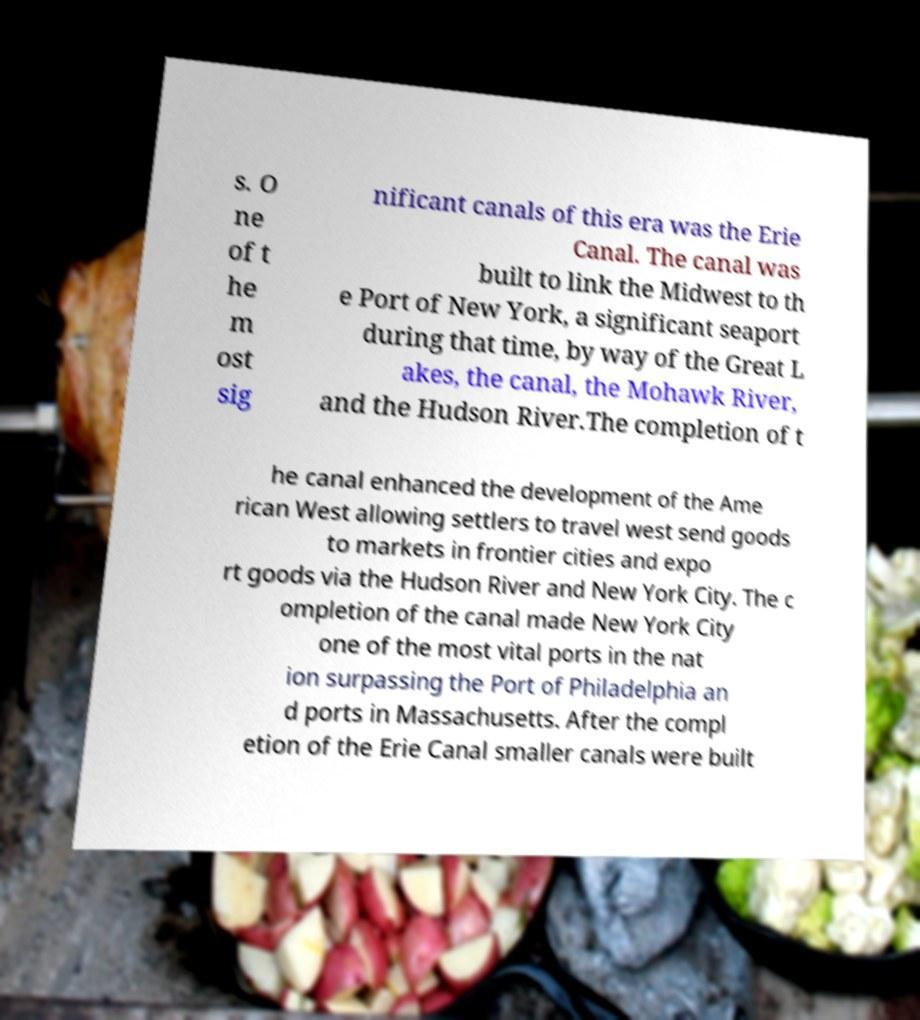Please identify and transcribe the text found in this image. s. O ne of t he m ost sig nificant canals of this era was the Erie Canal. The canal was built to link the Midwest to th e Port of New York, a significant seaport during that time, by way of the Great L akes, the canal, the Mohawk River, and the Hudson River.The completion of t he canal enhanced the development of the Ame rican West allowing settlers to travel west send goods to markets in frontier cities and expo rt goods via the Hudson River and New York City. The c ompletion of the canal made New York City one of the most vital ports in the nat ion surpassing the Port of Philadelphia an d ports in Massachusetts. After the compl etion of the Erie Canal smaller canals were built 